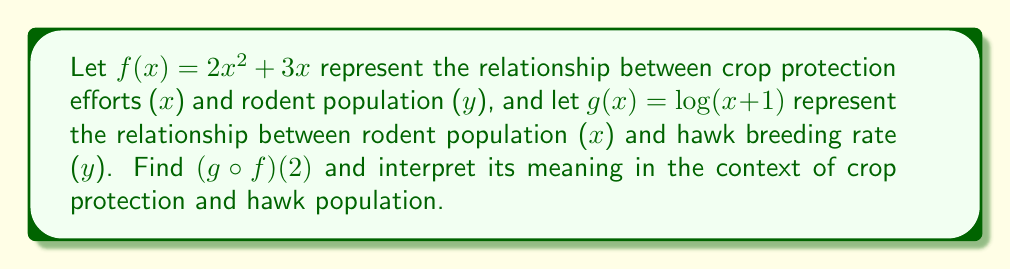Provide a solution to this math problem. To solve this problem, we'll follow these steps:

1) First, we need to find $f(2)$:
   $f(2) = 2(2)^2 + 3(2) = 2(4) + 6 = 14$

2) Now we need to find $g(f(2))$, which is equivalent to $g(14)$:
   $g(14) = \log(14+1) = \log(15)$

3) Therefore, $(g \circ f)(2) = \log(15)$

Interpretation:
The value $x = 2$ represents the level of crop protection efforts. 
$f(2) = 14$ means that this level of crop protection results in a rodent population of 14 units.
$(g \circ f)(2) = \log(15)$ ≈ 1.18 represents the hawk breeding rate corresponding to this rodent population.

In the context of crop protection and hawk population:
A crop protection effort level of 2 units leads to a rodent population that results in a hawk breeding rate of approximately 1.18 units. This suggests that the crop protection efforts indirectly support the hawk population by maintaining a suitable rodent population for the hawks to prey upon.
Answer: $(g \circ f)(2) = \log(15)$ 